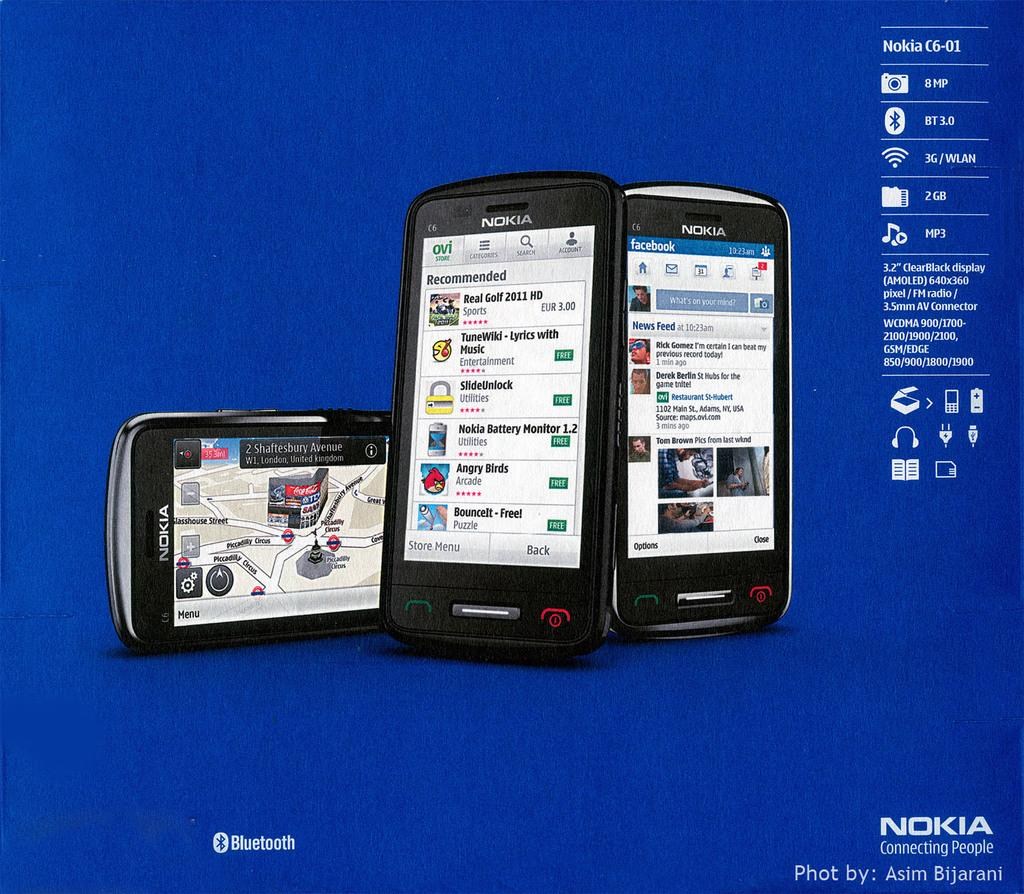Provide a one-sentence caption for the provided image. Nokia is the brand displayed on these three smart phones. 